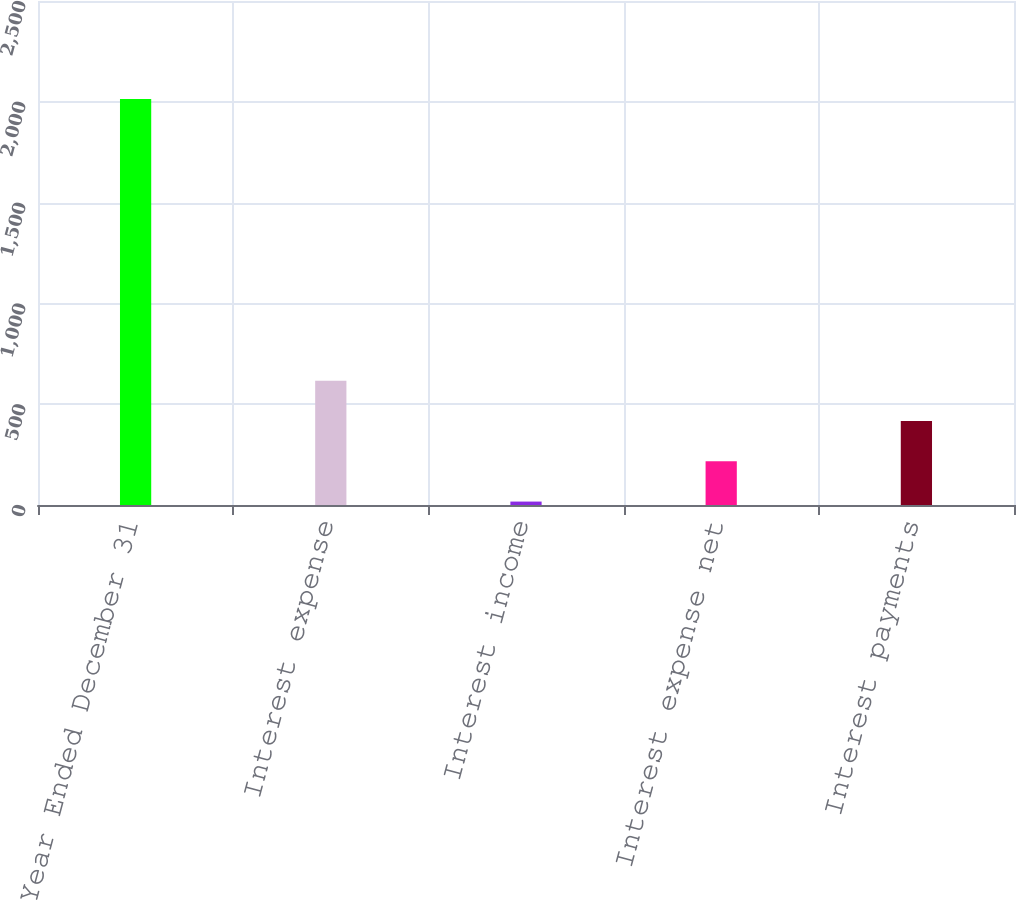Convert chart. <chart><loc_0><loc_0><loc_500><loc_500><bar_chart><fcel>Year Ended December 31<fcel>Interest expense<fcel>Interest income<fcel>Interest expense net<fcel>Interest payments<nl><fcel>2014<fcel>616.1<fcel>17<fcel>216.7<fcel>416.4<nl></chart> 